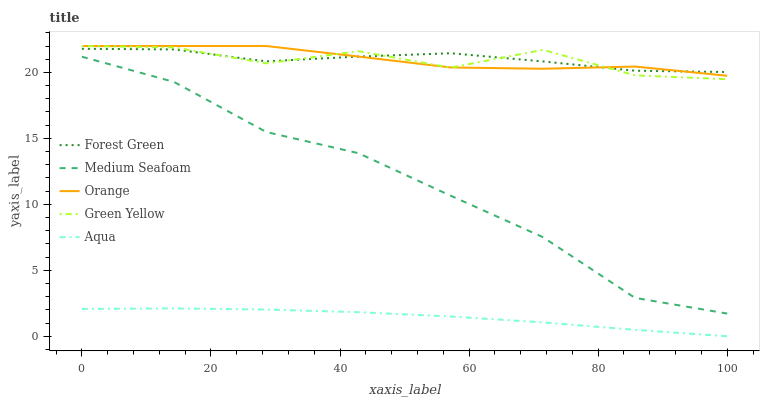Does Aqua have the minimum area under the curve?
Answer yes or no. Yes. Does Orange have the maximum area under the curve?
Answer yes or no. Yes. Does Forest Green have the minimum area under the curve?
Answer yes or no. No. Does Forest Green have the maximum area under the curve?
Answer yes or no. No. Is Aqua the smoothest?
Answer yes or no. Yes. Is Green Yellow the roughest?
Answer yes or no. Yes. Is Forest Green the smoothest?
Answer yes or no. No. Is Forest Green the roughest?
Answer yes or no. No. Does Aqua have the lowest value?
Answer yes or no. Yes. Does Green Yellow have the lowest value?
Answer yes or no. No. Does Green Yellow have the highest value?
Answer yes or no. Yes. Does Forest Green have the highest value?
Answer yes or no. No. Is Aqua less than Green Yellow?
Answer yes or no. Yes. Is Green Yellow greater than Aqua?
Answer yes or no. Yes. Does Green Yellow intersect Orange?
Answer yes or no. Yes. Is Green Yellow less than Orange?
Answer yes or no. No. Is Green Yellow greater than Orange?
Answer yes or no. No. Does Aqua intersect Green Yellow?
Answer yes or no. No. 